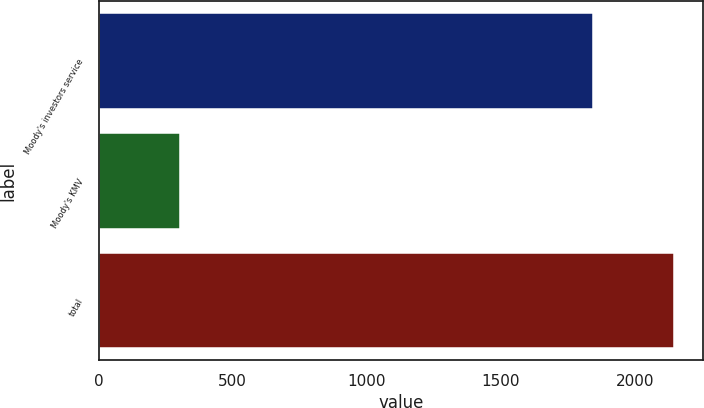<chart> <loc_0><loc_0><loc_500><loc_500><bar_chart><fcel>Moody's investors service<fcel>Moody's KMV<fcel>total<nl><fcel>1843<fcel>304<fcel>2147<nl></chart> 